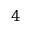Convert formula to latex. <formula><loc_0><loc_0><loc_500><loc_500>4</formula> 